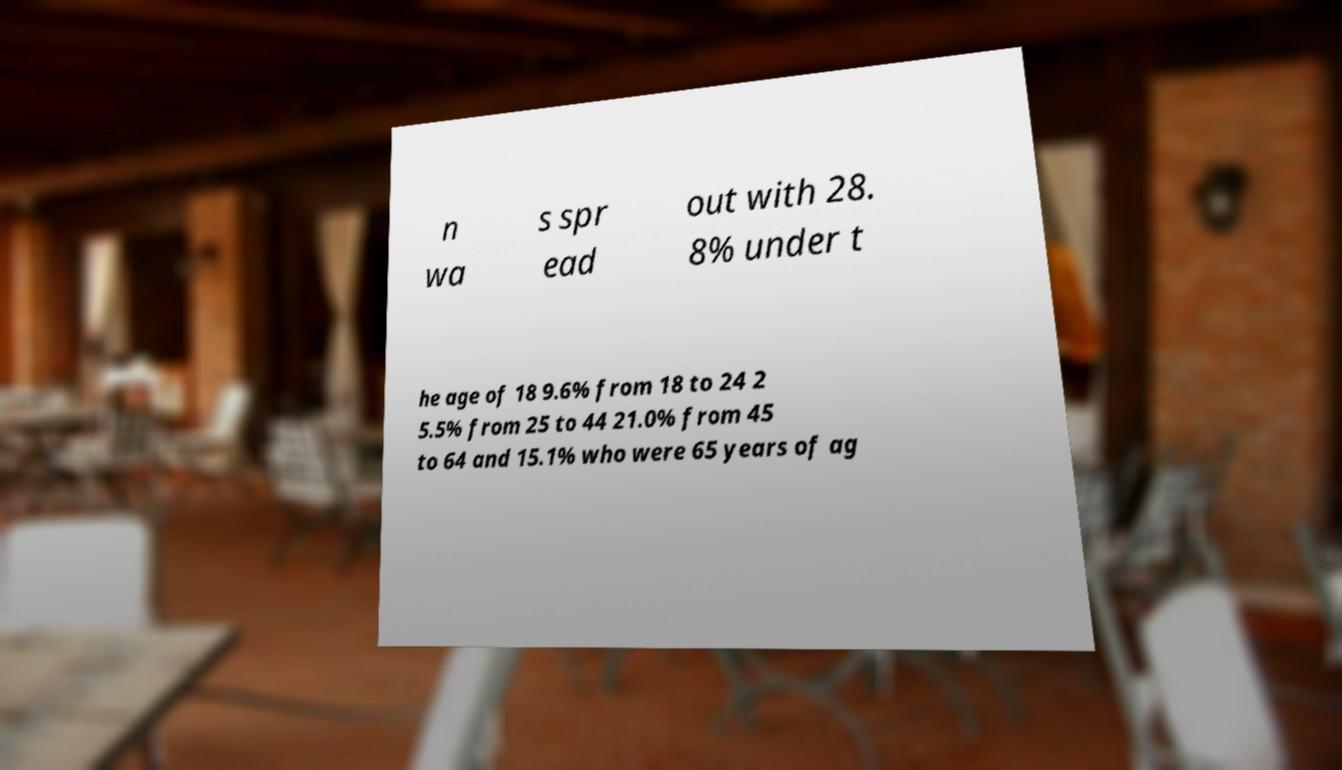Please read and relay the text visible in this image. What does it say? n wa s spr ead out with 28. 8% under t he age of 18 9.6% from 18 to 24 2 5.5% from 25 to 44 21.0% from 45 to 64 and 15.1% who were 65 years of ag 